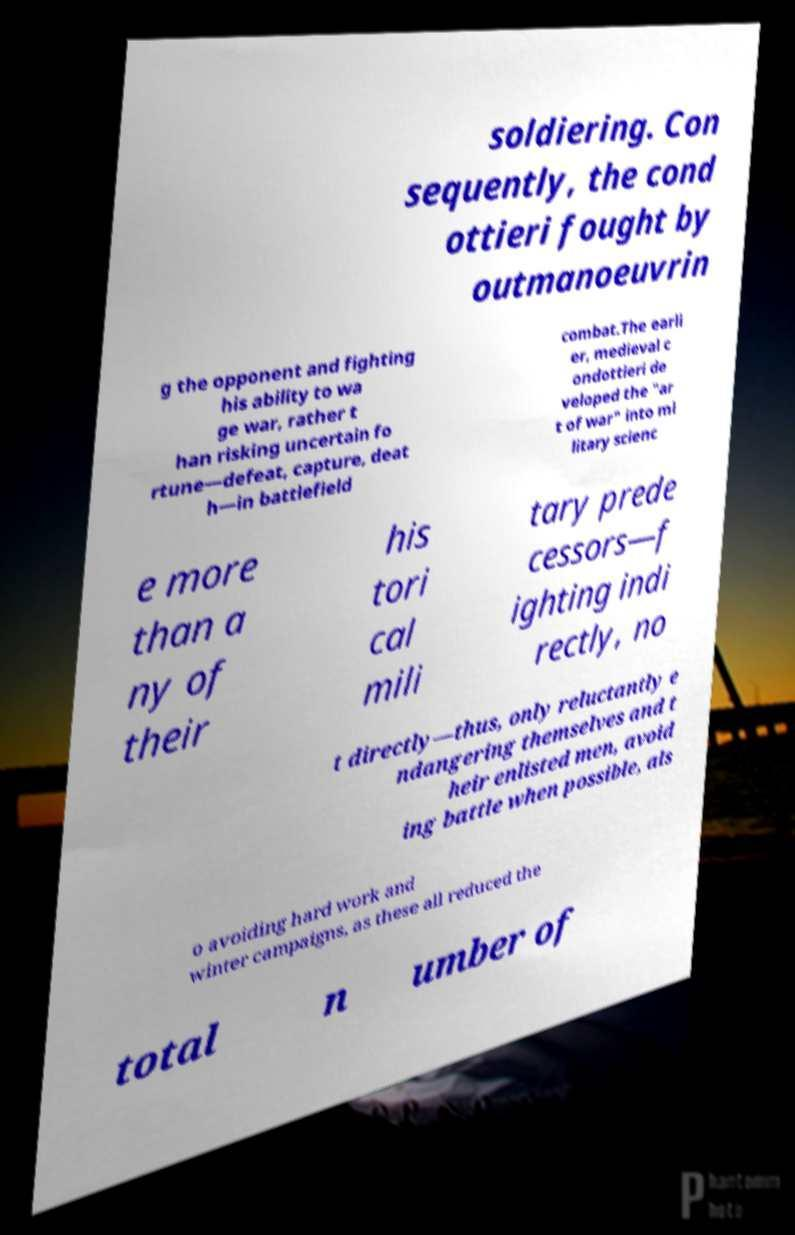For documentation purposes, I need the text within this image transcribed. Could you provide that? soldiering. Con sequently, the cond ottieri fought by outmanoeuvrin g the opponent and fighting his ability to wa ge war, rather t han risking uncertain fo rtune—defeat, capture, deat h—in battlefield combat.The earli er, medieval c ondottieri de veloped the "ar t of war" into mi litary scienc e more than a ny of their his tori cal mili tary prede cessors—f ighting indi rectly, no t directly—thus, only reluctantly e ndangering themselves and t heir enlisted men, avoid ing battle when possible, als o avoiding hard work and winter campaigns, as these all reduced the total n umber of 